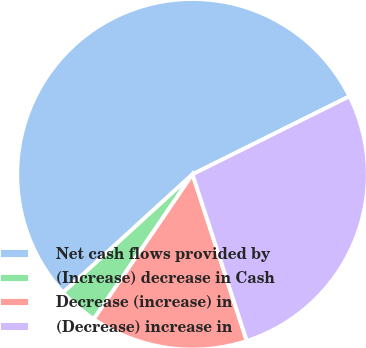<chart> <loc_0><loc_0><loc_500><loc_500><pie_chart><fcel>Net cash flows provided by<fcel>(Increase) decrease in Cash<fcel>Decrease (increase) in<fcel>(Decrease) increase in<nl><fcel>54.44%<fcel>3.69%<fcel>14.54%<fcel>27.33%<nl></chart> 